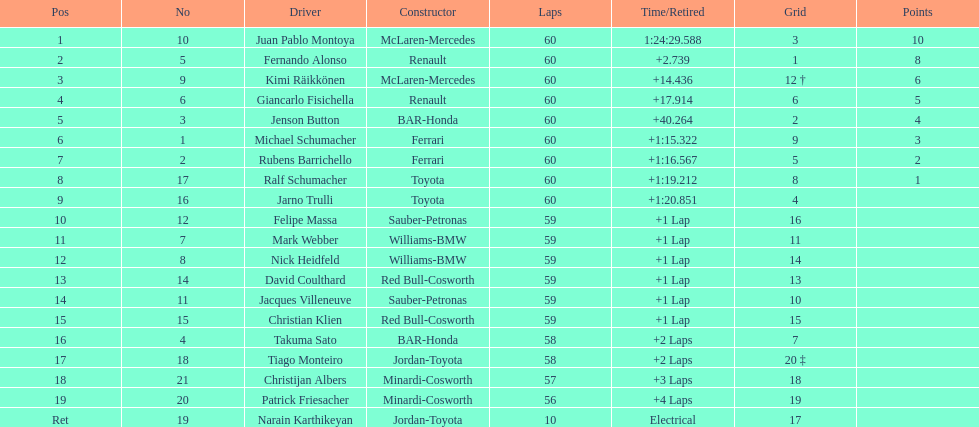How many drivers received points from the race? 8. 